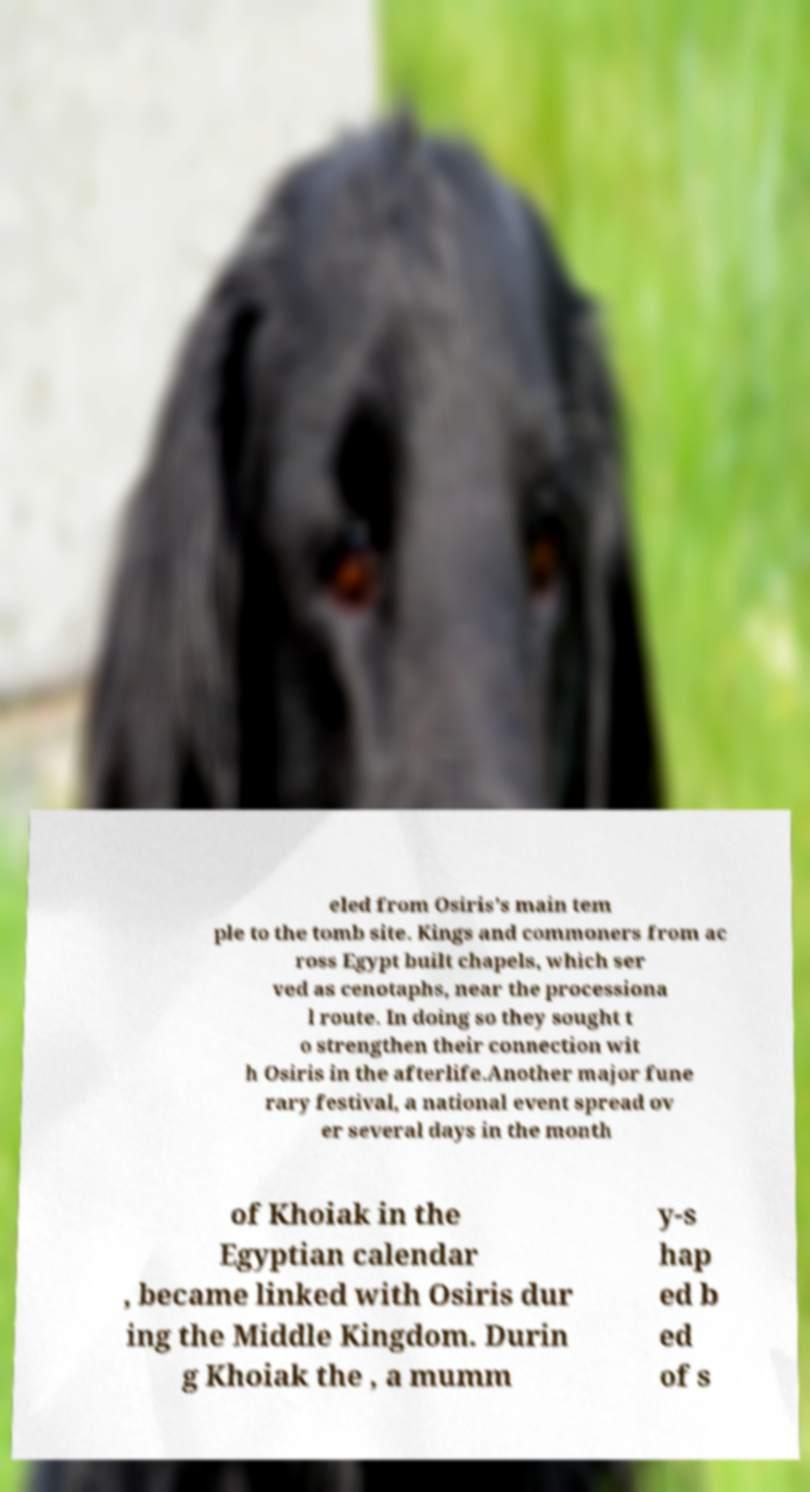For documentation purposes, I need the text within this image transcribed. Could you provide that? eled from Osiris's main tem ple to the tomb site. Kings and commoners from ac ross Egypt built chapels, which ser ved as cenotaphs, near the processiona l route. In doing so they sought t o strengthen their connection wit h Osiris in the afterlife.Another major fune rary festival, a national event spread ov er several days in the month of Khoiak in the Egyptian calendar , became linked with Osiris dur ing the Middle Kingdom. Durin g Khoiak the , a mumm y-s hap ed b ed of s 